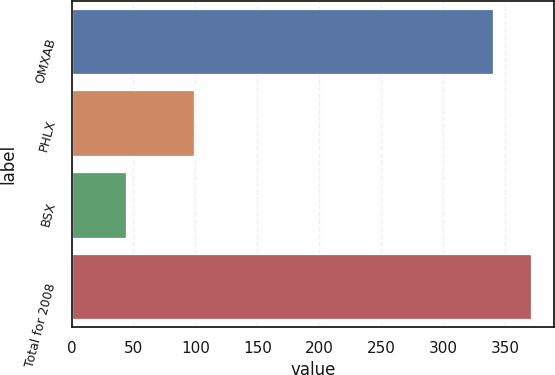<chart> <loc_0><loc_0><loc_500><loc_500><bar_chart><fcel>OMXAB<fcel>PHLX<fcel>BSX<fcel>Total for 2008<nl><fcel>340<fcel>99<fcel>44<fcel>371.2<nl></chart> 